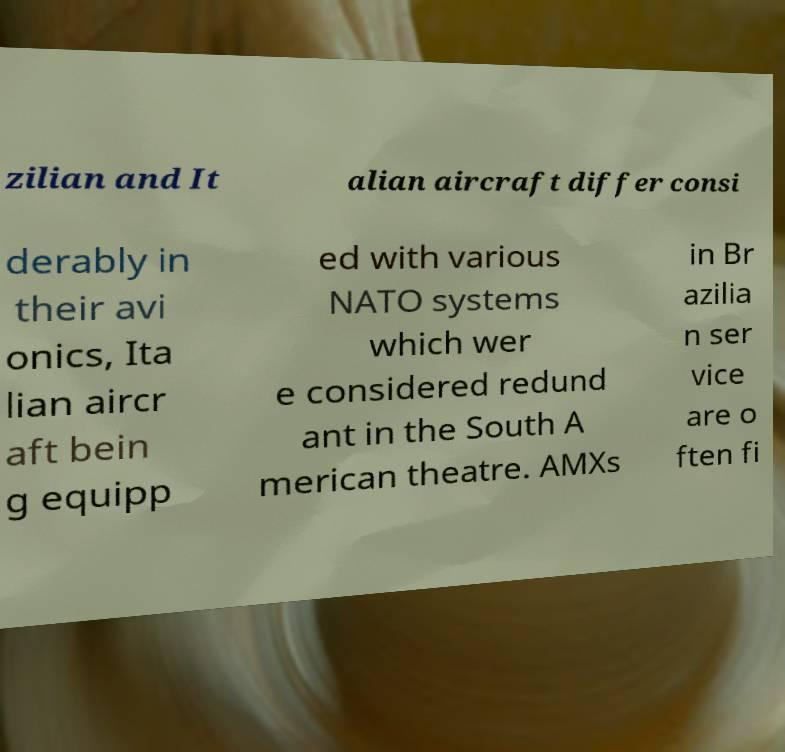I need the written content from this picture converted into text. Can you do that? zilian and It alian aircraft differ consi derably in their avi onics, Ita lian aircr aft bein g equipp ed with various NATO systems which wer e considered redund ant in the South A merican theatre. AMXs in Br azilia n ser vice are o ften fi 